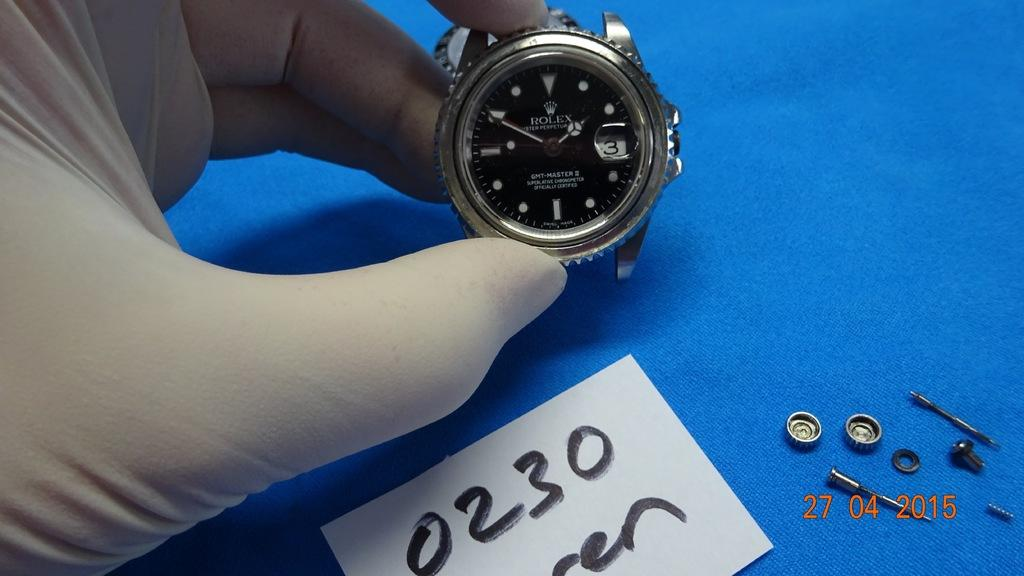<image>
Render a clear and concise summary of the photo. A photo thatr was taken on April 04 of 2015 of a strapless wrist watch. 